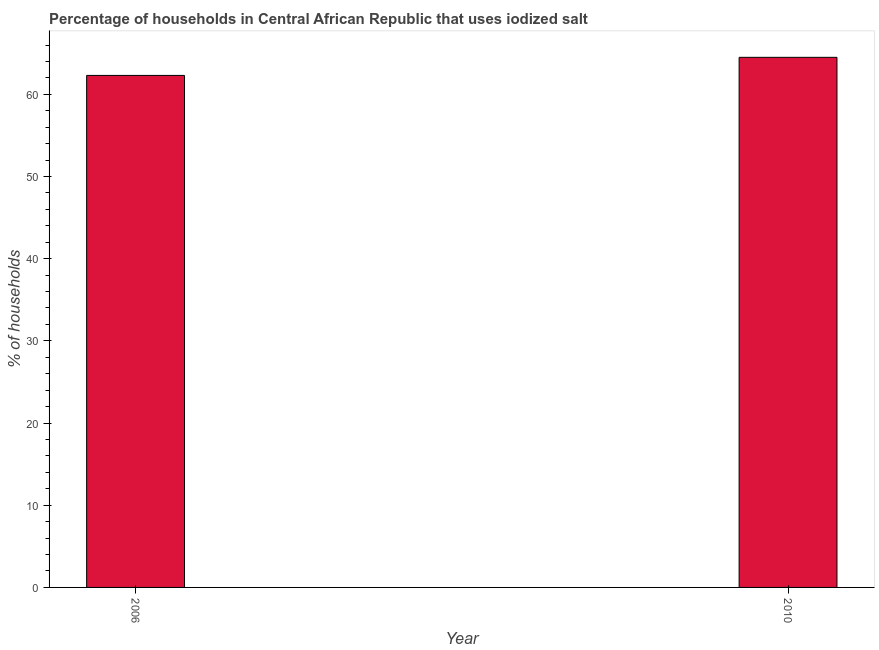Does the graph contain any zero values?
Ensure brevity in your answer.  No. Does the graph contain grids?
Provide a succinct answer. No. What is the title of the graph?
Offer a terse response. Percentage of households in Central African Republic that uses iodized salt. What is the label or title of the X-axis?
Give a very brief answer. Year. What is the label or title of the Y-axis?
Offer a very short reply. % of households. What is the percentage of households where iodized salt is consumed in 2010?
Provide a short and direct response. 64.5. Across all years, what is the maximum percentage of households where iodized salt is consumed?
Ensure brevity in your answer.  64.5. Across all years, what is the minimum percentage of households where iodized salt is consumed?
Offer a very short reply. 62.3. What is the sum of the percentage of households where iodized salt is consumed?
Your answer should be compact. 126.8. What is the average percentage of households where iodized salt is consumed per year?
Provide a short and direct response. 63.4. What is the median percentage of households where iodized salt is consumed?
Keep it short and to the point. 63.4. In how many years, is the percentage of households where iodized salt is consumed greater than 14 %?
Your response must be concise. 2. Is the percentage of households where iodized salt is consumed in 2006 less than that in 2010?
Make the answer very short. Yes. In how many years, is the percentage of households where iodized salt is consumed greater than the average percentage of households where iodized salt is consumed taken over all years?
Offer a very short reply. 1. How many bars are there?
Provide a short and direct response. 2. Are all the bars in the graph horizontal?
Your answer should be very brief. No. How many years are there in the graph?
Ensure brevity in your answer.  2. Are the values on the major ticks of Y-axis written in scientific E-notation?
Make the answer very short. No. What is the % of households in 2006?
Your answer should be very brief. 62.3. What is the % of households of 2010?
Make the answer very short. 64.5. What is the difference between the % of households in 2006 and 2010?
Your answer should be very brief. -2.2. 